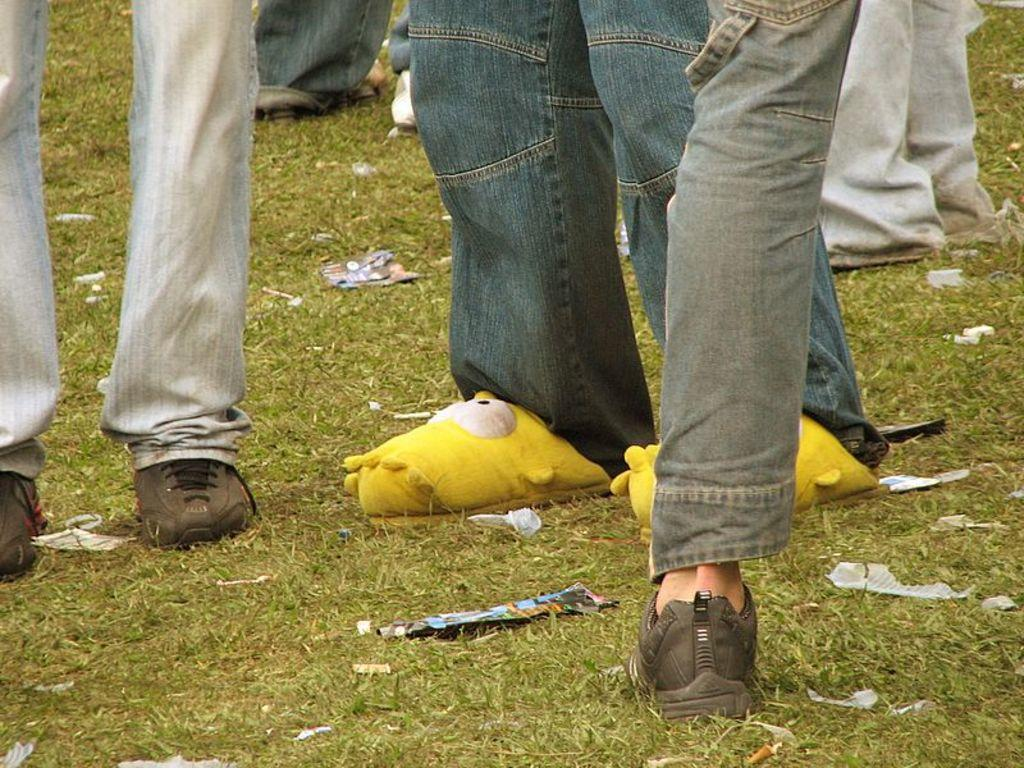Where was the image taken? The image was taken outdoors. What type of surface can be seen under the people's feet? There is a ground with grass in the image. How many people are standing in the image? A few people are standing on the ground in the image. What type of brass instrument is being played by the people in the image? There is no brass instrument or any musical instrument visible in the image. What type of cabbage is growing in the background of the image? There is no cabbage or any vegetation visible in the image; it only shows a ground with grass and a few people standing on it. 